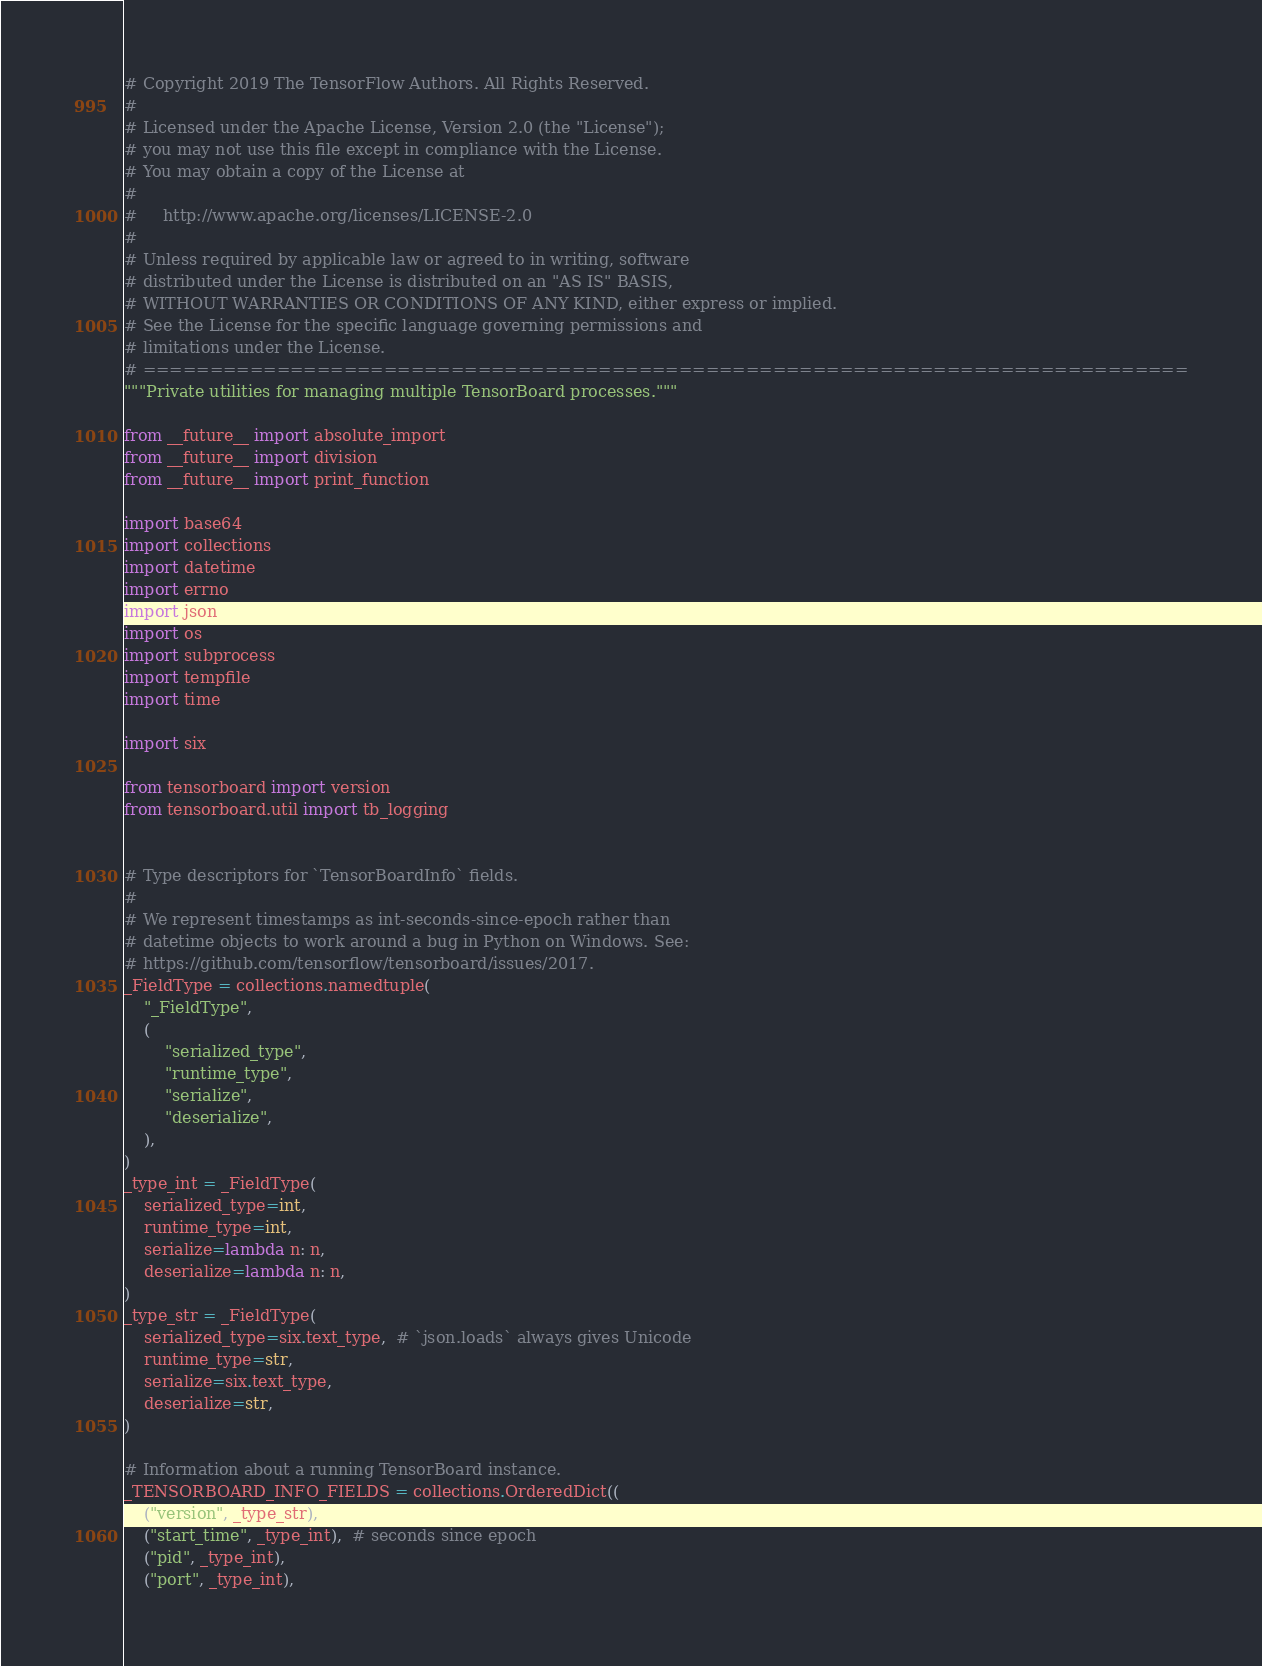<code> <loc_0><loc_0><loc_500><loc_500><_Python_># Copyright 2019 The TensorFlow Authors. All Rights Reserved.
#
# Licensed under the Apache License, Version 2.0 (the "License");
# you may not use this file except in compliance with the License.
# You may obtain a copy of the License at
#
#     http://www.apache.org/licenses/LICENSE-2.0
#
# Unless required by applicable law or agreed to in writing, software
# distributed under the License is distributed on an "AS IS" BASIS,
# WITHOUT WARRANTIES OR CONDITIONS OF ANY KIND, either express or implied.
# See the License for the specific language governing permissions and
# limitations under the License.
# ==============================================================================
"""Private utilities for managing multiple TensorBoard processes."""

from __future__ import absolute_import
from __future__ import division
from __future__ import print_function

import base64
import collections
import datetime
import errno
import json
import os
import subprocess
import tempfile
import time

import six

from tensorboard import version
from tensorboard.util import tb_logging


# Type descriptors for `TensorBoardInfo` fields.
#
# We represent timestamps as int-seconds-since-epoch rather than
# datetime objects to work around a bug in Python on Windows. See:
# https://github.com/tensorflow/tensorboard/issues/2017.
_FieldType = collections.namedtuple(
    "_FieldType",
    (
        "serialized_type",
        "runtime_type",
        "serialize",
        "deserialize",
    ),
)
_type_int = _FieldType(
    serialized_type=int,
    runtime_type=int,
    serialize=lambda n: n,
    deserialize=lambda n: n,
)
_type_str = _FieldType(
    serialized_type=six.text_type,  # `json.loads` always gives Unicode
    runtime_type=str,
    serialize=six.text_type,
    deserialize=str,
)

# Information about a running TensorBoard instance.
_TENSORBOARD_INFO_FIELDS = collections.OrderedDict((
    ("version", _type_str),
    ("start_time", _type_int),  # seconds since epoch
    ("pid", _type_int),
    ("port", _type_int),</code> 